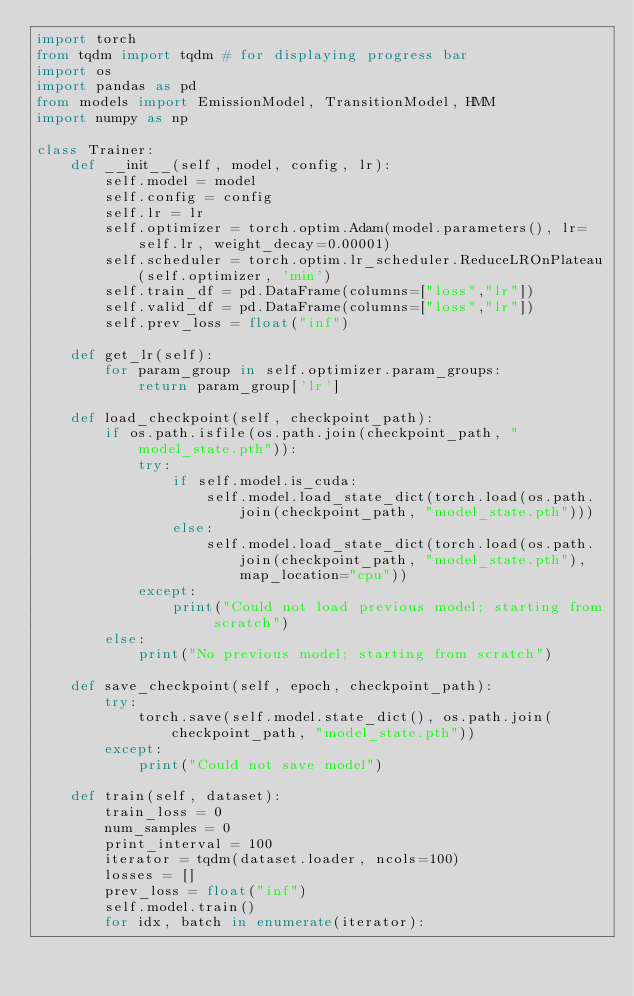Convert code to text. <code><loc_0><loc_0><loc_500><loc_500><_Python_>import torch
from tqdm import tqdm # for displaying progress bar
import os
import pandas as pd
from models import EmissionModel, TransitionModel, HMM
import numpy as np

class Trainer:
    def __init__(self, model, config, lr):
        self.model = model
        self.config = config
        self.lr = lr
        self.optimizer = torch.optim.Adam(model.parameters(), lr=self.lr, weight_decay=0.00001)
        self.scheduler = torch.optim.lr_scheduler.ReduceLROnPlateau(self.optimizer, 'min')
        self.train_df = pd.DataFrame(columns=["loss","lr"])
        self.valid_df = pd.DataFrame(columns=["loss","lr"])
        self.prev_loss = float("inf")

    def get_lr(self):
        for param_group in self.optimizer.param_groups:
            return param_group['lr']

    def load_checkpoint(self, checkpoint_path):
        if os.path.isfile(os.path.join(checkpoint_path, "model_state.pth")):
            try:
                if self.model.is_cuda:
                    self.model.load_state_dict(torch.load(os.path.join(checkpoint_path, "model_state.pth")))
                else:
                    self.model.load_state_dict(torch.load(os.path.join(checkpoint_path, "model_state.pth"), map_location="cpu"))
            except:
                print("Could not load previous model; starting from scratch")
        else:
            print("No previous model; starting from scratch")

    def save_checkpoint(self, epoch, checkpoint_path):
        try:
            torch.save(self.model.state_dict(), os.path.join(checkpoint_path, "model_state.pth"))
        except:
            print("Could not save model")
        
    def train(self, dataset):
        train_loss = 0
        num_samples = 0
        print_interval = 100
        iterator = tqdm(dataset.loader, ncols=100)
        losses = []
        prev_loss = float("inf")
        self.model.train()
        for idx, batch in enumerate(iterator):</code> 